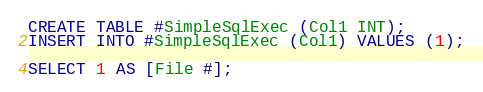Convert code to text. <code><loc_0><loc_0><loc_500><loc_500><_SQL_>CREATE TABLE #SimpleSqlExec (Col1 INT);
INSERT INTO #SimpleSqlExec (Col1) VALUES (1);

SELECT 1 AS [File #];
</code> 